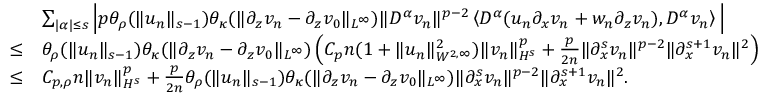Convert formula to latex. <formula><loc_0><loc_0><loc_500><loc_500>\begin{array} { r l } & { \sum _ { | \alpha | \leq s } \left | p \theta _ { \rho } ( \| u _ { n } \| _ { s - 1 } ) \theta _ { \kappa } ( \| \partial _ { z } v _ { n } - \partial _ { z } v _ { 0 } \| _ { L ^ { \infty } } ) \| D ^ { \alpha } v _ { n } \| ^ { p - 2 } \left \langle D ^ { \alpha } ( u _ { n } \partial _ { x } v _ { n } + w _ { n } \partial _ { z } v _ { n } ) , D ^ { \alpha } v _ { n } \right \rangle \right | } \\ { \leq } & { \theta _ { \rho } ( \| u _ { n } \| _ { s - 1 } ) \theta _ { \kappa } ( \| \partial _ { z } v _ { n } - \partial _ { z } v _ { 0 } \| _ { L ^ { \infty } } ) \left ( C _ { p } n ( 1 + \| u _ { n } \| _ { W ^ { 2 , \infty } } ^ { 2 } ) \| v _ { n } \| _ { H ^ { s } } ^ { p } + \frac { p } 2 n } \| \partial _ { x } ^ { s } v _ { n } \| ^ { p - 2 } \| \partial _ { x } ^ { s + 1 } v _ { n } \| ^ { 2 } \right ) } \\ { \leq } & { C _ { p , \rho } n \| v _ { n } \| _ { H ^ { s } } ^ { p } + \frac { p } 2 n } \theta _ { \rho } ( \| u _ { n } \| _ { s - 1 } ) \theta _ { \kappa } ( \| \partial _ { z } v _ { n } - \partial _ { z } v _ { 0 } \| _ { L ^ { \infty } } ) \| \partial _ { x } ^ { s } v _ { n } \| ^ { p - 2 } \| \partial _ { x } ^ { s + 1 } v _ { n } \| ^ { 2 } . } \end{array}</formula> 